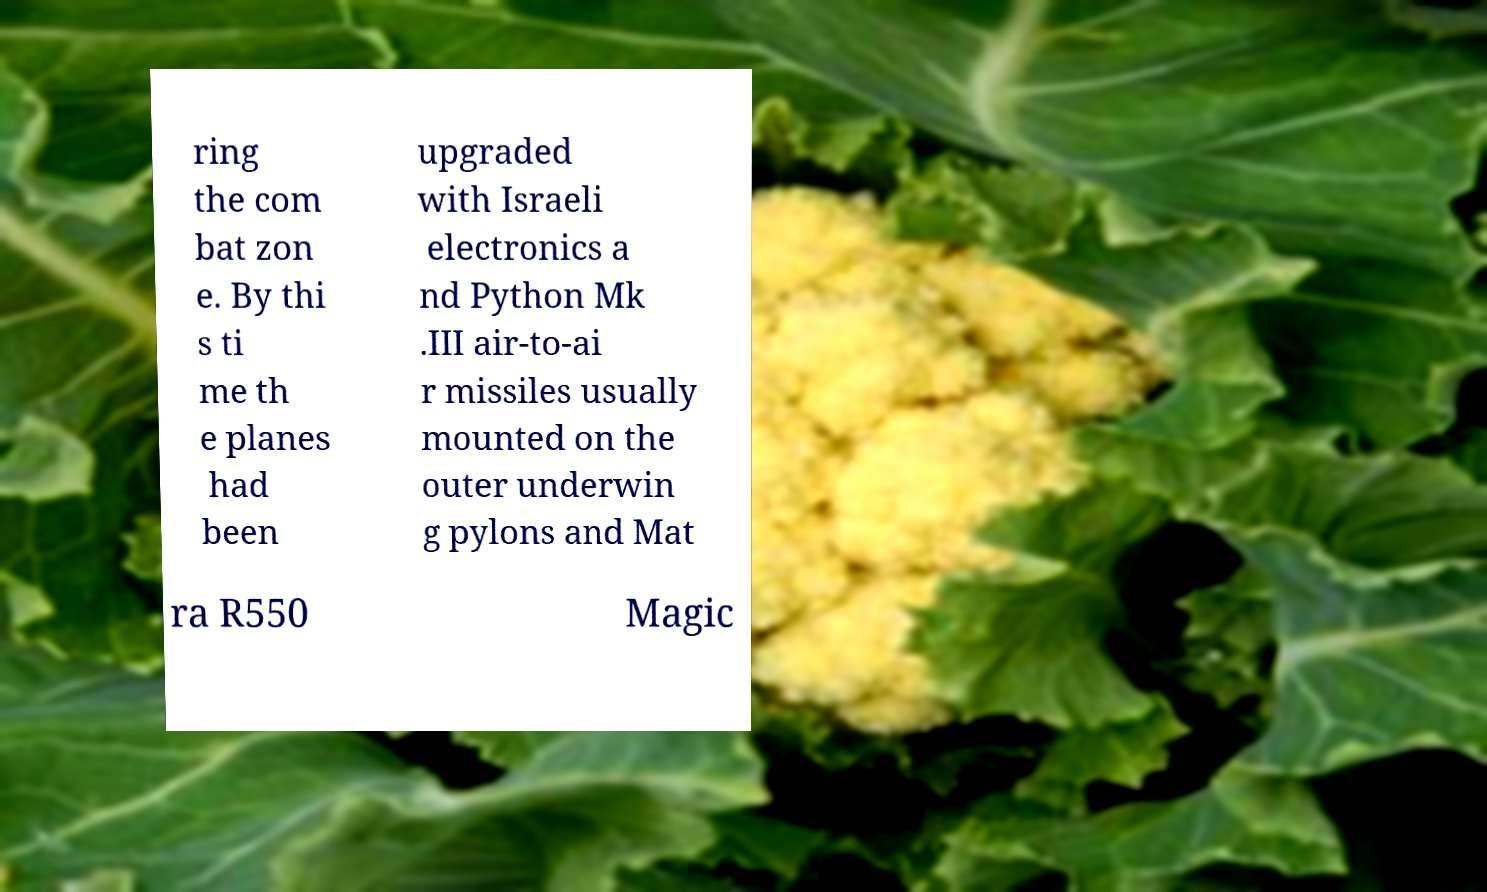Can you read and provide the text displayed in the image?This photo seems to have some interesting text. Can you extract and type it out for me? ring the com bat zon e. By thi s ti me th e planes had been upgraded with Israeli electronics a nd Python Mk .III air-to-ai r missiles usually mounted on the outer underwin g pylons and Mat ra R550 Magic 